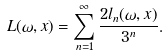<formula> <loc_0><loc_0><loc_500><loc_500>L ( \omega , x ) = \sum _ { n = 1 } ^ { \infty } \frac { 2 l _ { n } ( \omega , x ) } { 3 ^ { n } } .</formula> 